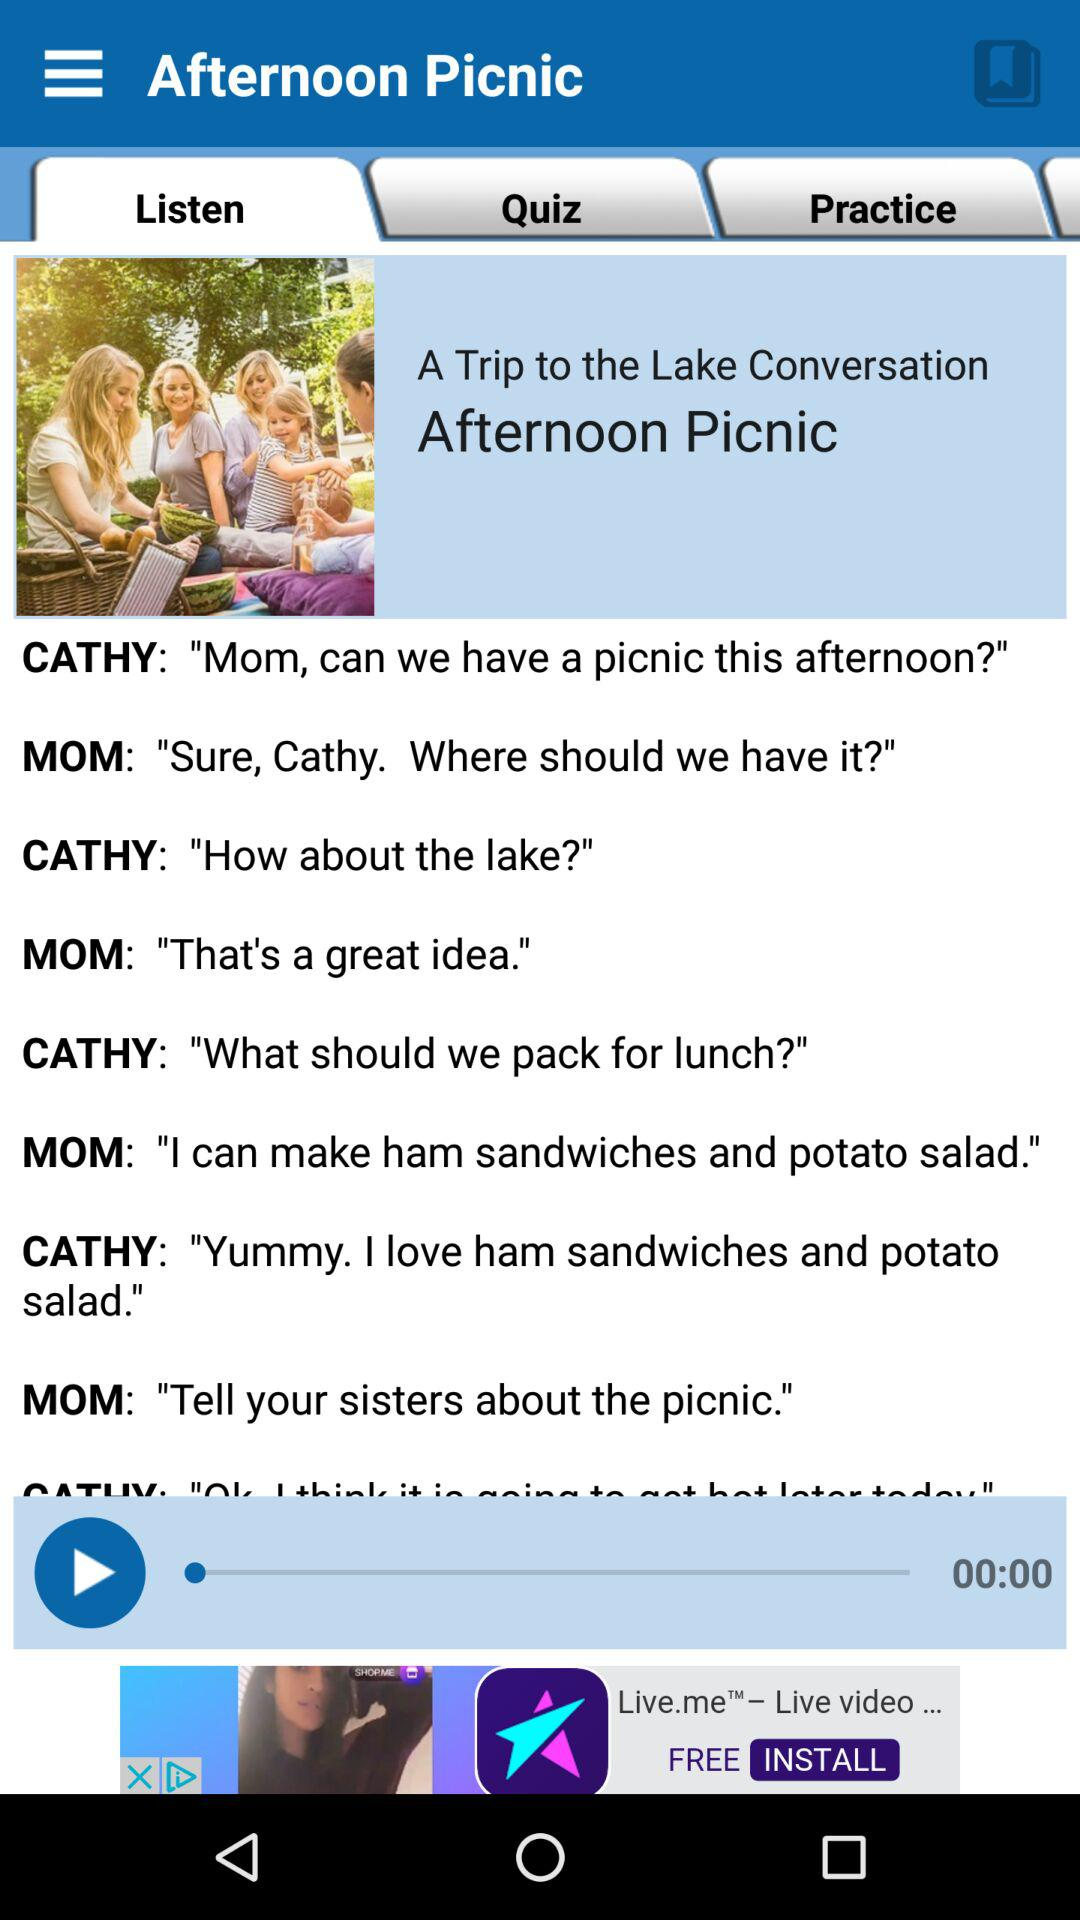What topic has been chosen to listen? The topic is "A Trip to the Lake Conversation Afternoon Picnic". 